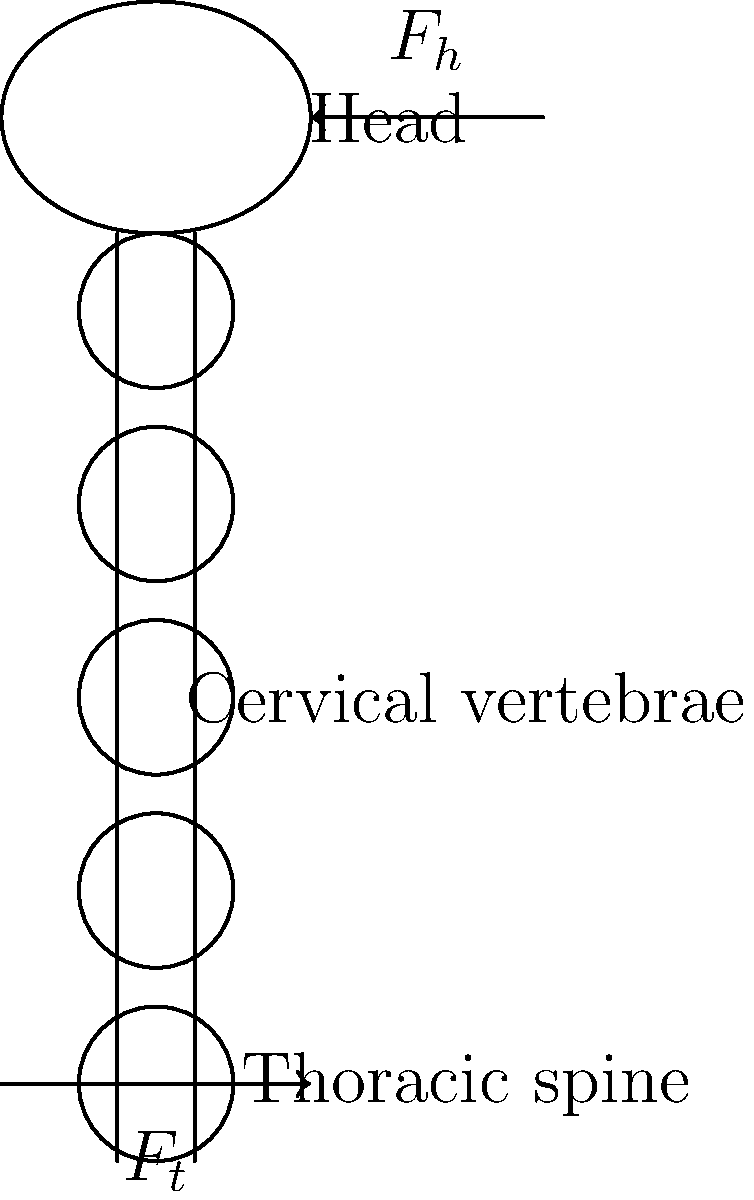During a whiplash injury, a child's head experiences a sudden acceleration-deceleration force. If the force applied to the head ($F_h$) is 100 N and the tensile force along the spine ($F_t$) is 80 N, what is the net force acting on the cervical spine, assuming these are the primary forces involved? To solve this problem, we need to follow these steps:

1. Identify the forces acting on the cervical spine:
   - $F_h$: Force applied to the head (100 N)
   - $F_t$: Tensile force along the spine (80 N)

2. Determine the direction of these forces:
   - $F_h$ acts horizontally, causing the head to move backward
   - $F_t$ acts vertically, along the spine

3. Since these forces are perpendicular to each other, we can use the Pythagorean theorem to calculate the net force:

   $F_{net} = \sqrt{F_h^2 + F_t^2}$

4. Substitute the given values:

   $F_{net} = \sqrt{(100 N)^2 + (80 N)^2}$

5. Calculate:

   $F_{net} = \sqrt{10,000 N^2 + 6,400 N^2}$
   $F_{net} = \sqrt{16,400 N^2}$
   $F_{net} = 128.06 N$

6. Round to two decimal places:

   $F_{net} \approx 128.06 N$

Thus, the net force acting on the cervical spine is approximately 128.06 N.
Answer: 128.06 N 